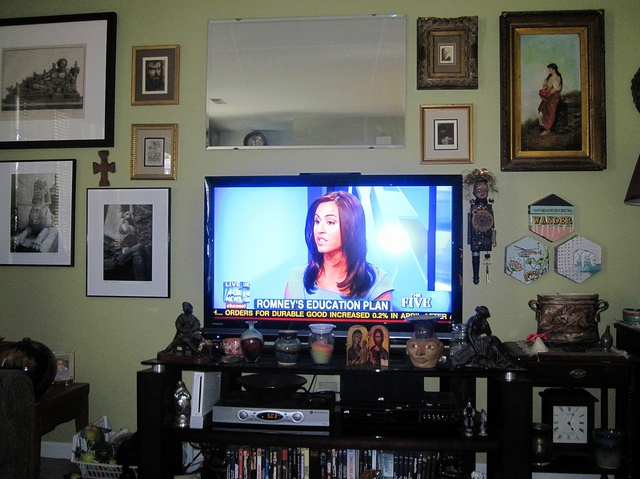Describe the objects in this image and their specific colors. I can see tv in black, lightblue, navy, and darkblue tones, people in black, lavender, blue, and lightpink tones, vase in black, gray, and navy tones, clock in black, gray, and purple tones, and vase in black, gray, brown, and navy tones in this image. 